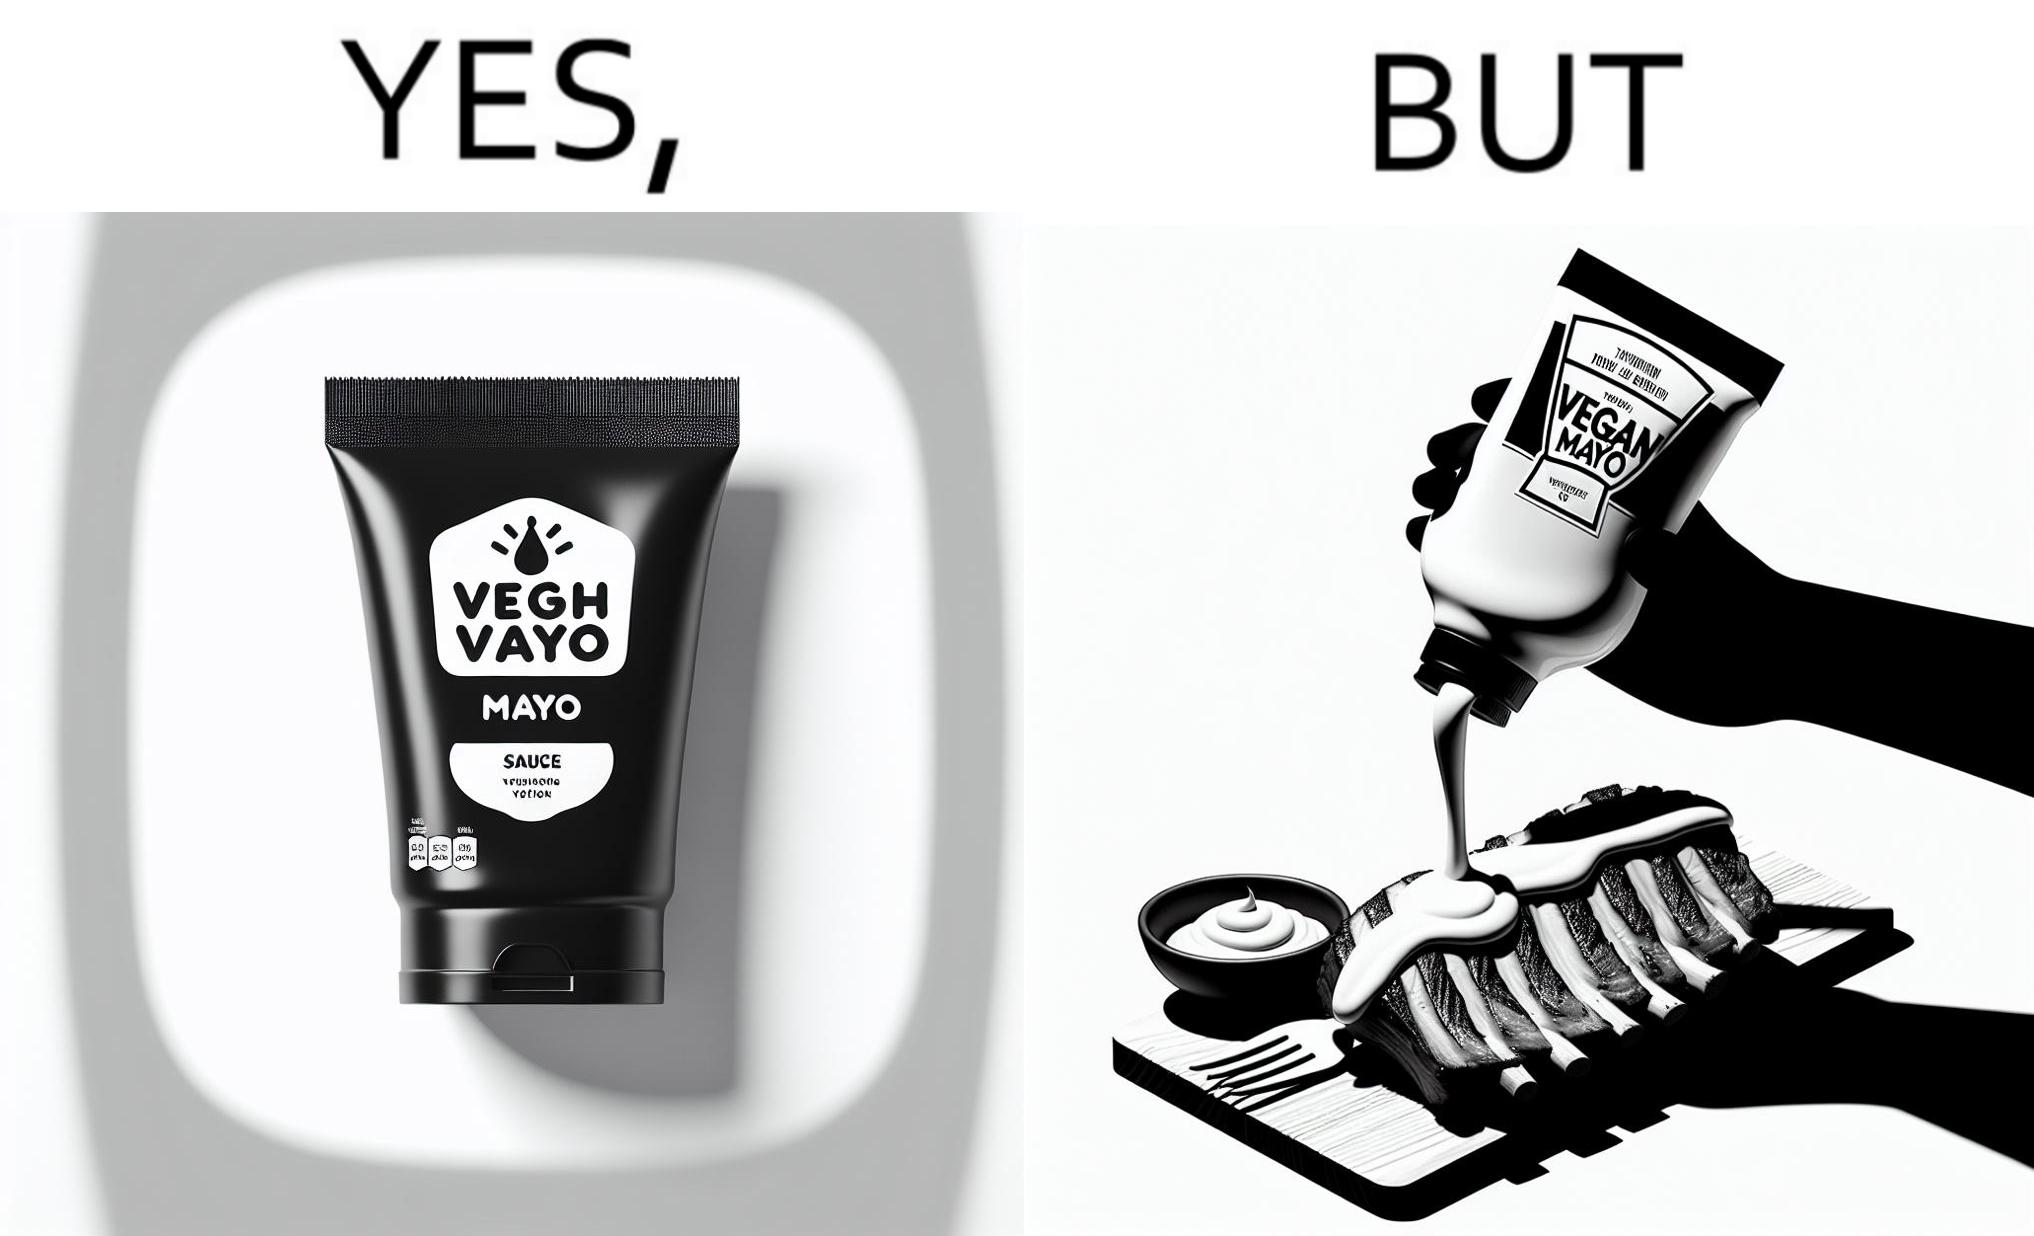Is this image satirical or non-satirical? Yes, this image is satirical. 